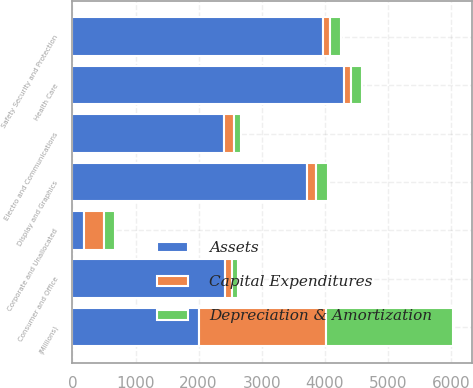Convert chart to OTSL. <chart><loc_0><loc_0><loc_500><loc_500><stacked_bar_chart><ecel><fcel>(Millions)<fcel>Health Care<fcel>Consumer and Office<fcel>Safety Security and Protection<fcel>Display and Graphics<fcel>Electro and Communications<fcel>Corporate and Unallocated<nl><fcel>Assets<fcel>2012<fcel>4304<fcel>2421<fcel>3966<fcel>3714<fcel>2398<fcel>186.5<nl><fcel>Depreciation & Amortization<fcel>2012<fcel>169<fcel>109<fcel>175<fcel>190<fcel>109<fcel>183<nl><fcel>Capital Expenditures<fcel>2012<fcel>113<fcel>103<fcel>121<fcel>156<fcel>159<fcel>311<nl></chart> 